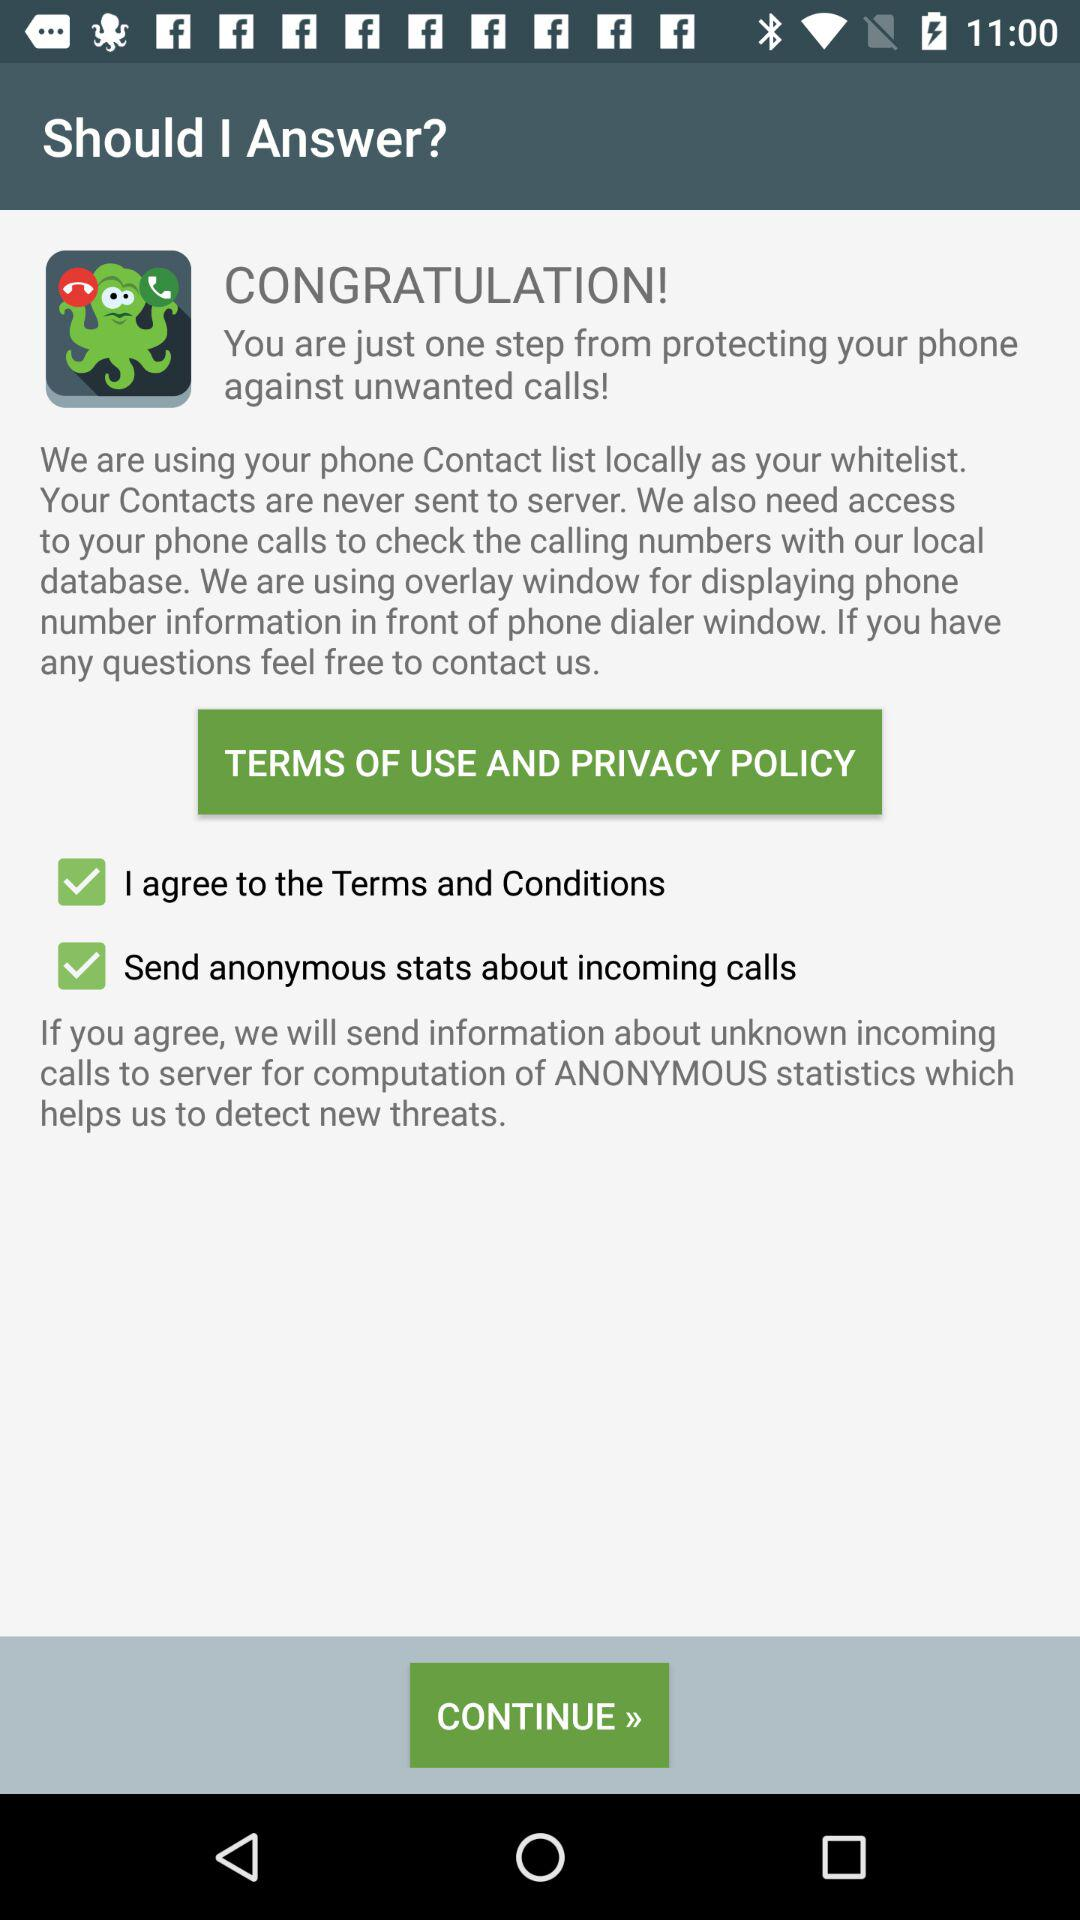What is the current state of "Send anonymous stats about incoming calls"? The status is "on". 